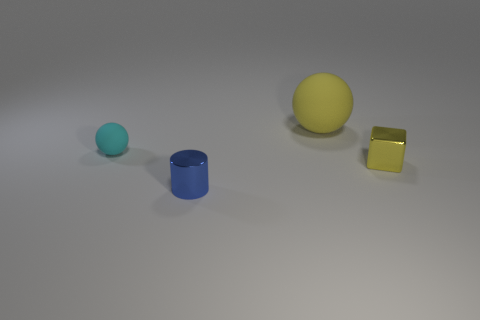Add 4 tiny rubber objects. How many objects exist? 8 Subtract all cubes. How many objects are left? 3 Subtract all big spheres. Subtract all yellow objects. How many objects are left? 1 Add 2 small matte balls. How many small matte balls are left? 3 Add 3 shiny cylinders. How many shiny cylinders exist? 4 Subtract 0 brown balls. How many objects are left? 4 